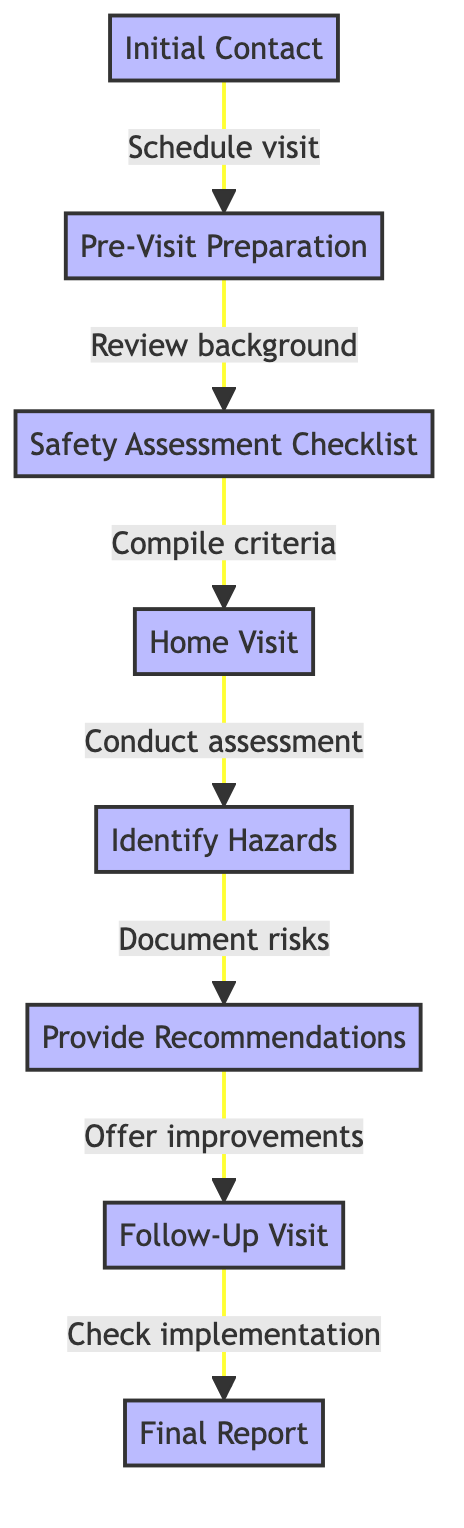What is the first step in the home safety assessment process? The first step listed in the diagram is "Initial Contact," which indicates the starting point of the process.
Answer: Initial Contact How many total steps are there in the flowchart? By counting each distinct step shown in the diagram, there are a total of 8 steps.
Answer: 8 Which step comes after "Home Visit"? Following the "Home Visit" step in the diagram, the next step is "Identify Hazards."
Answer: Identify Hazards What action is taken in the "Provide Recommendations" step? This step involves offering suggestions for improving safety, which is the main action described in this node.
Answer: Offer recommendations What is the last step in the assessment process? The final step indicated in the diagram is "Final Report," which summarizes the overall assessment.
Answer: Final Report Which steps are connected directly to "Identify Hazards"? The node "Identify Hazards" has direct connections to "Home Visit" (which it follows) and to "Provide Recommendations" (which follows after it).
Answer: Home Visit, Provide Recommendations What is the relationship between "Pre-Visit Preparation" and "Safety Assessment Checklist"? "Pre-Visit Preparation" leads directly to "Safety Assessment Checklist," indicating that preparation is necessary before compiling the checklist.
Answer: Leads to What needs to be documented during the "Identify Hazards" step? During this step, the focus is on documenting any safety hazards or risks that are found within the home.
Answer: Document hazards What is the purpose of the "Follow-Up Visit"? The purpose of this visit is to ensure that the recommendations provided earlier have been implemented effectively.
Answer: Check implementation 